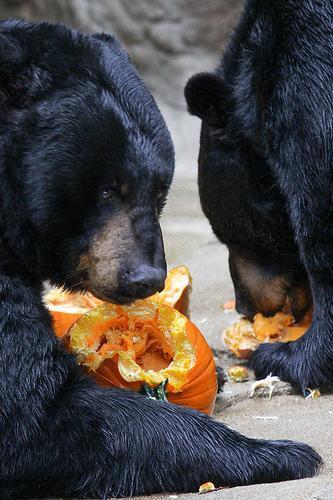How many bears are pictured?
Give a very brief answer. 2. 